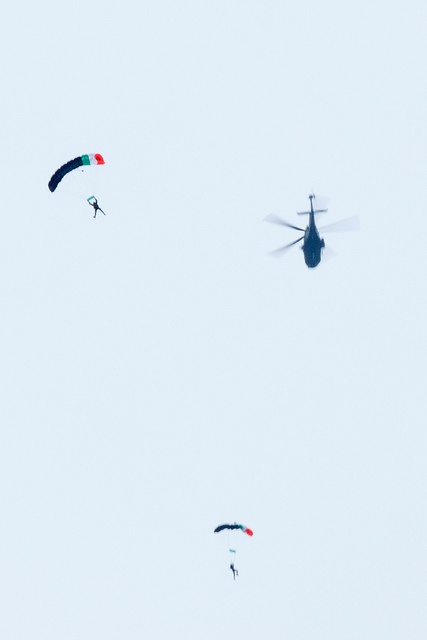Describe the objects in this image and their specific colors. I can see people in white, lightgray, darkgray, gray, and lightblue tones and people in white, navy, gray, and darkgray tones in this image. 